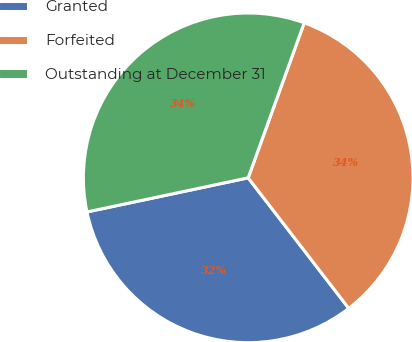Convert chart. <chart><loc_0><loc_0><loc_500><loc_500><pie_chart><fcel>Granted<fcel>Forfeited<fcel>Outstanding at December 31<nl><fcel>32.13%<fcel>34.03%<fcel>33.84%<nl></chart> 